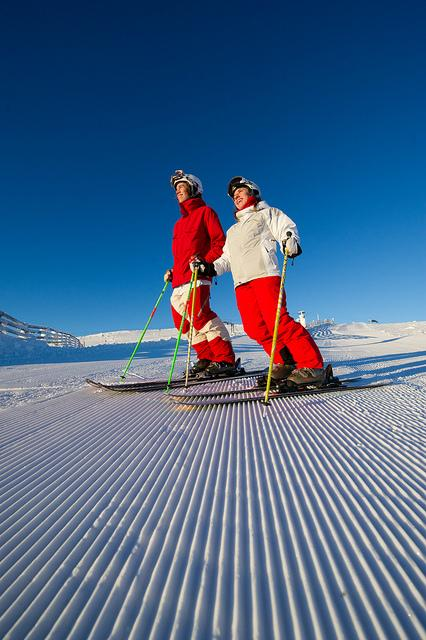How did these grooves get set in snow?

Choices:
A) natural phenomenon
B) freak storm
C) magic
D) snow groomer snow groomer 